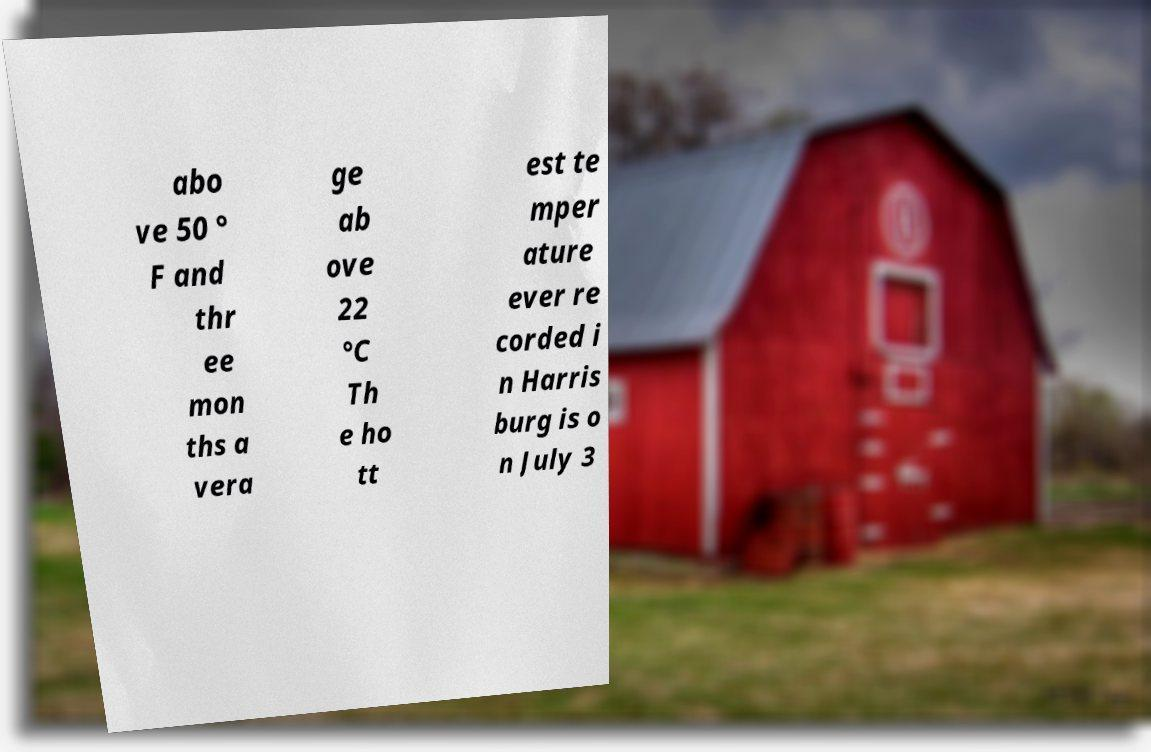Could you extract and type out the text from this image? abo ve 50 ° F and thr ee mon ths a vera ge ab ove 22 °C Th e ho tt est te mper ature ever re corded i n Harris burg is o n July 3 